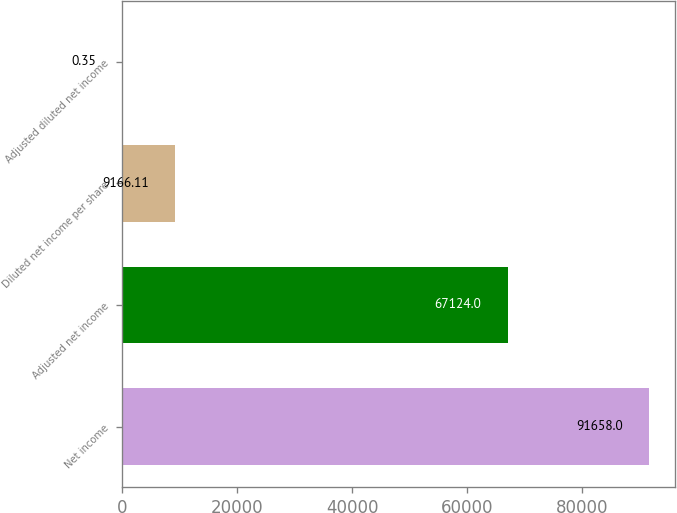Convert chart. <chart><loc_0><loc_0><loc_500><loc_500><bar_chart><fcel>Net income<fcel>Adjusted net income<fcel>Diluted net income per share<fcel>Adjusted diluted net income<nl><fcel>91658<fcel>67124<fcel>9166.11<fcel>0.35<nl></chart> 